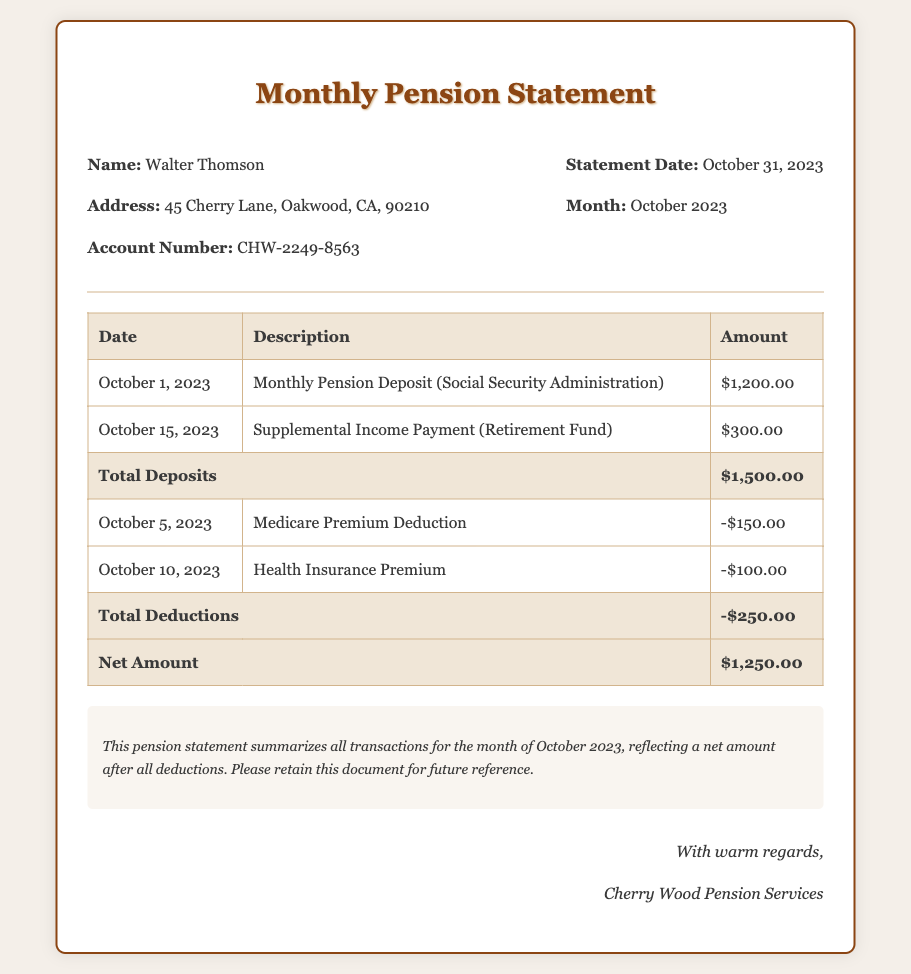What is the name on the pension statement? The name is listed at the top of the statement as Walter Thomson.
Answer: Walter Thomson What is the total amount of deposits? The total amount of deposits is summarized in the transaction table as $1,500.00.
Answer: $1,500.00 What deductions were made on October 5, 2023? The deduction made on this date is specified in the transaction table as Medicare Premium Deduction.
Answer: Medicare Premium Deduction What is the date of the statement? The date of the statement is mentioned in the header section as October 31, 2023.
Answer: October 31, 2023 What is the net amount after deductions? The net amount is calculated and displayed at the bottom of the transaction table as $1,250.00.
Answer: $1,250.00 How much was the health insurance premium? The amount for the health insurance premium is listed as -$100.00 in the transaction table.
Answer: -$100.00 Which organization is responsible for the pension statement? The organization is identified at the bottom of the document as Cherry Wood Pension Services.
Answer: Cherry Wood Pension Services What was the supplemental income payment amount? The supplemental income payment amount is noted in the transaction table as $300.00.
Answer: $300.00 